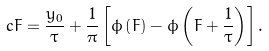Convert formula to latex. <formula><loc_0><loc_0><loc_500><loc_500>c F = \frac { y _ { 0 } } { \tau } + \frac { 1 } { \pi } \left [ \phi \left ( F \right ) - \phi \left ( F + \frac { 1 } { \tau } \right ) \right ] .</formula> 